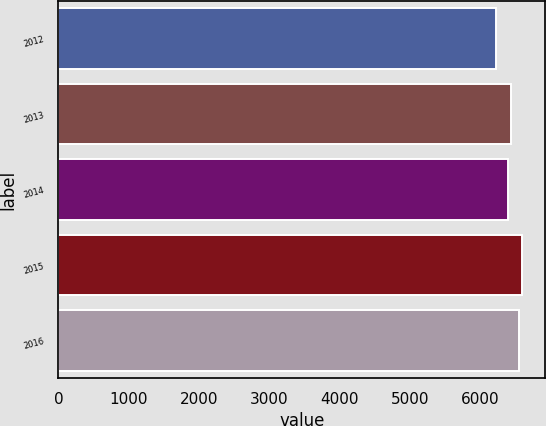Convert chart to OTSL. <chart><loc_0><loc_0><loc_500><loc_500><bar_chart><fcel>2012<fcel>2013<fcel>2014<fcel>2015<fcel>2016<nl><fcel>6225<fcel>6430<fcel>6387<fcel>6587<fcel>6542<nl></chart> 